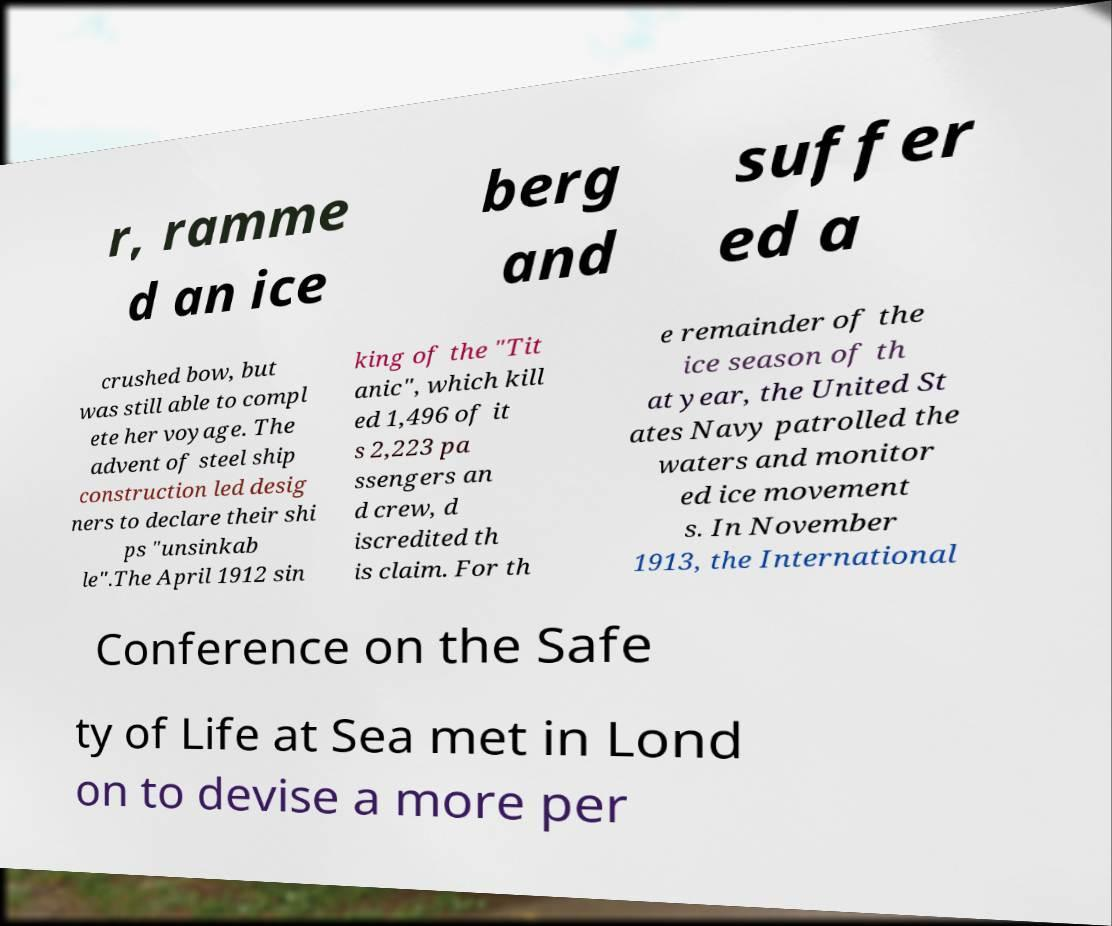There's text embedded in this image that I need extracted. Can you transcribe it verbatim? r, ramme d an ice berg and suffer ed a crushed bow, but was still able to compl ete her voyage. The advent of steel ship construction led desig ners to declare their shi ps "unsinkab le".The April 1912 sin king of the "Tit anic", which kill ed 1,496 of it s 2,223 pa ssengers an d crew, d iscredited th is claim. For th e remainder of the ice season of th at year, the United St ates Navy patrolled the waters and monitor ed ice movement s. In November 1913, the International Conference on the Safe ty of Life at Sea met in Lond on to devise a more per 